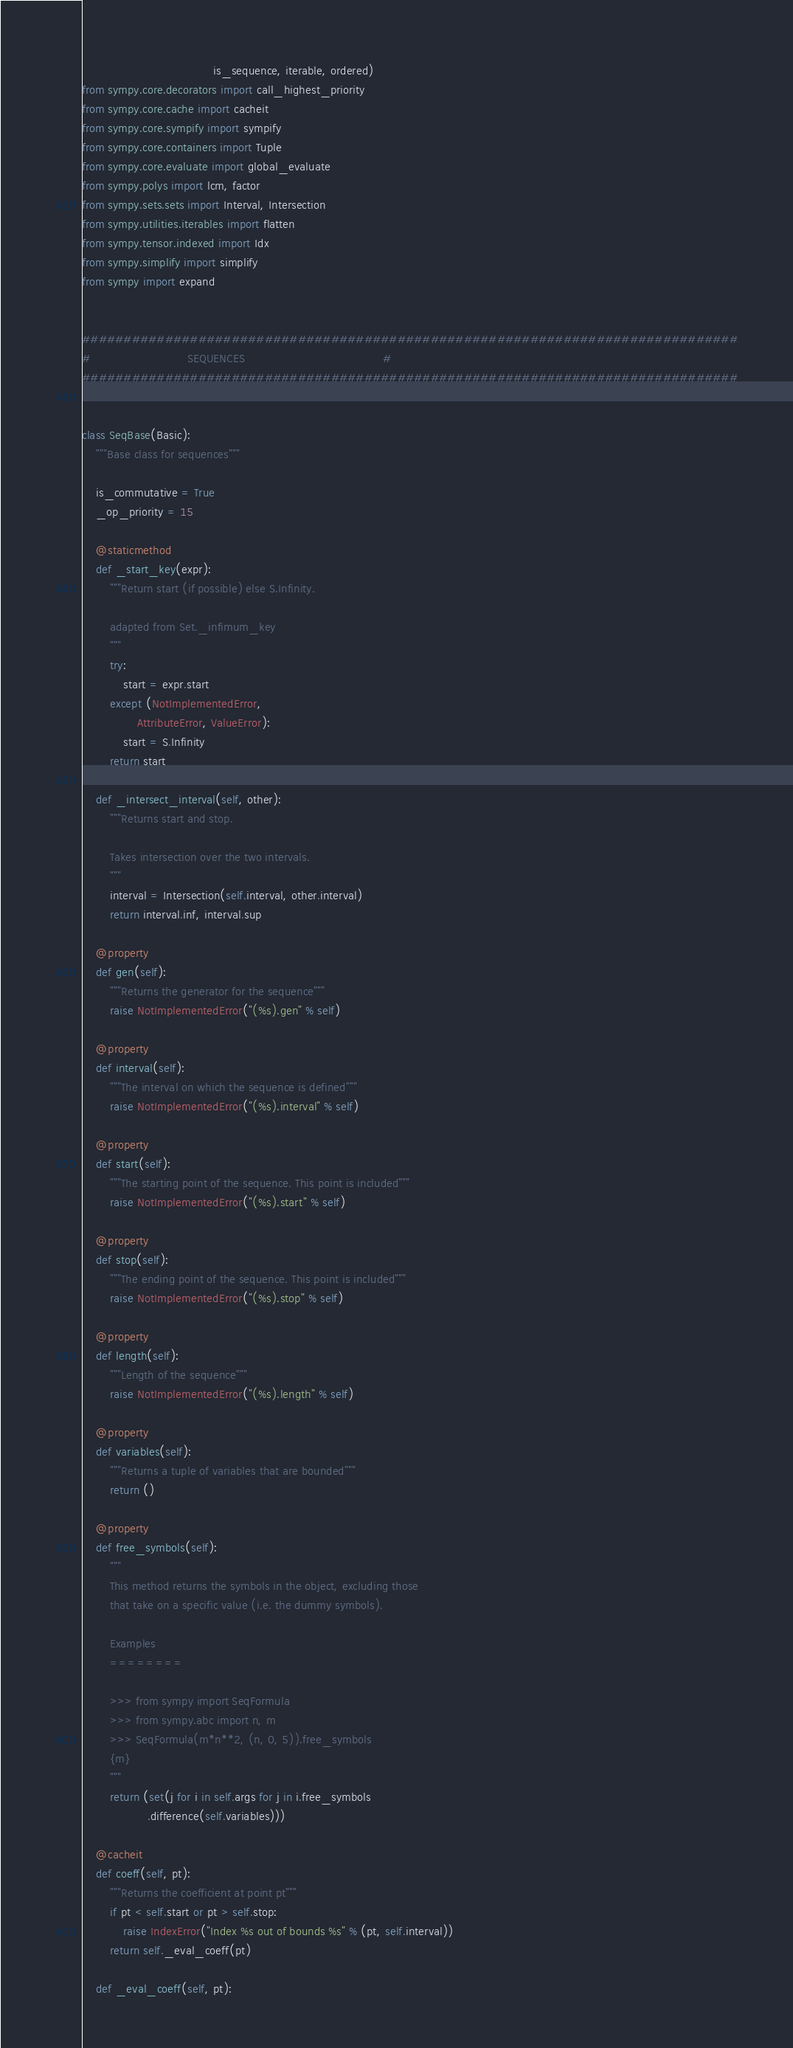<code> <loc_0><loc_0><loc_500><loc_500><_Python_>                                      is_sequence, iterable, ordered)
from sympy.core.decorators import call_highest_priority
from sympy.core.cache import cacheit
from sympy.core.sympify import sympify
from sympy.core.containers import Tuple
from sympy.core.evaluate import global_evaluate
from sympy.polys import lcm, factor
from sympy.sets.sets import Interval, Intersection
from sympy.utilities.iterables import flatten
from sympy.tensor.indexed import Idx
from sympy.simplify import simplify
from sympy import expand


###############################################################################
#                            SEQUENCES                                        #
###############################################################################


class SeqBase(Basic):
    """Base class for sequences"""

    is_commutative = True
    _op_priority = 15

    @staticmethod
    def _start_key(expr):
        """Return start (if possible) else S.Infinity.

        adapted from Set._infimum_key
        """
        try:
            start = expr.start
        except (NotImplementedError,
                AttributeError, ValueError):
            start = S.Infinity
        return start

    def _intersect_interval(self, other):
        """Returns start and stop.

        Takes intersection over the two intervals.
        """
        interval = Intersection(self.interval, other.interval)
        return interval.inf, interval.sup

    @property
    def gen(self):
        """Returns the generator for the sequence"""
        raise NotImplementedError("(%s).gen" % self)

    @property
    def interval(self):
        """The interval on which the sequence is defined"""
        raise NotImplementedError("(%s).interval" % self)

    @property
    def start(self):
        """The starting point of the sequence. This point is included"""
        raise NotImplementedError("(%s).start" % self)

    @property
    def stop(self):
        """The ending point of the sequence. This point is included"""
        raise NotImplementedError("(%s).stop" % self)

    @property
    def length(self):
        """Length of the sequence"""
        raise NotImplementedError("(%s).length" % self)

    @property
    def variables(self):
        """Returns a tuple of variables that are bounded"""
        return ()

    @property
    def free_symbols(self):
        """
        This method returns the symbols in the object, excluding those
        that take on a specific value (i.e. the dummy symbols).

        Examples
        ========

        >>> from sympy import SeqFormula
        >>> from sympy.abc import n, m
        >>> SeqFormula(m*n**2, (n, 0, 5)).free_symbols
        {m}
        """
        return (set(j for i in self.args for j in i.free_symbols
                   .difference(self.variables)))

    @cacheit
    def coeff(self, pt):
        """Returns the coefficient at point pt"""
        if pt < self.start or pt > self.stop:
            raise IndexError("Index %s out of bounds %s" % (pt, self.interval))
        return self._eval_coeff(pt)

    def _eval_coeff(self, pt):</code> 